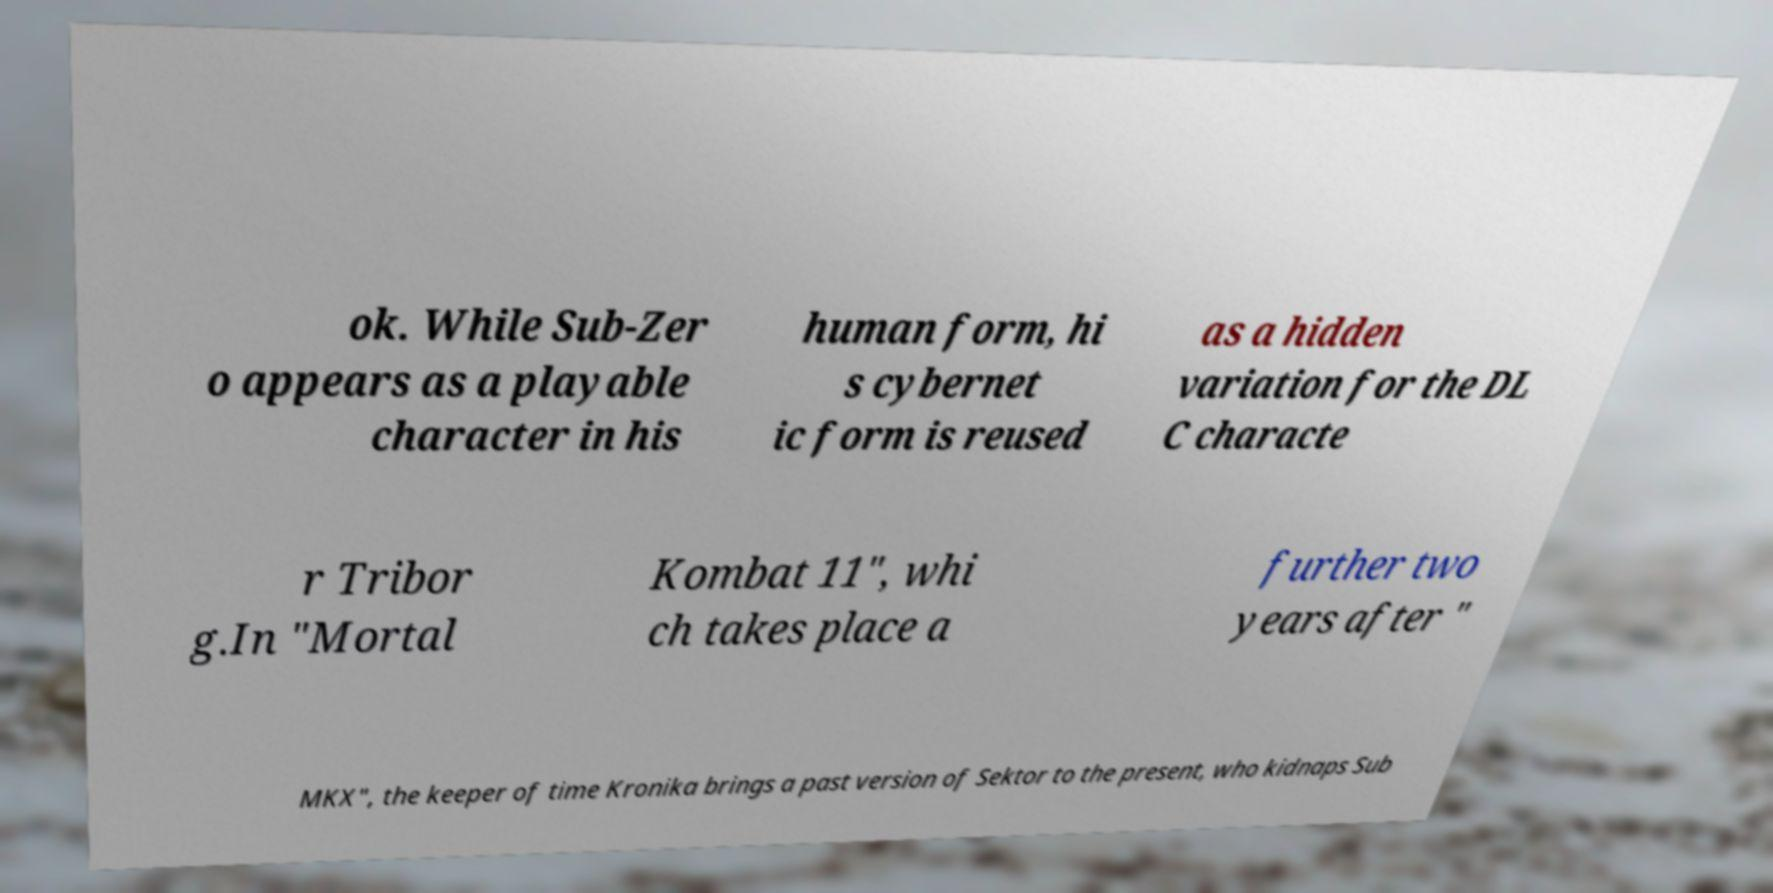Can you read and provide the text displayed in the image?This photo seems to have some interesting text. Can you extract and type it out for me? ok. While Sub-Zer o appears as a playable character in his human form, hi s cybernet ic form is reused as a hidden variation for the DL C characte r Tribor g.In "Mortal Kombat 11", whi ch takes place a further two years after " MKX", the keeper of time Kronika brings a past version of Sektor to the present, who kidnaps Sub 